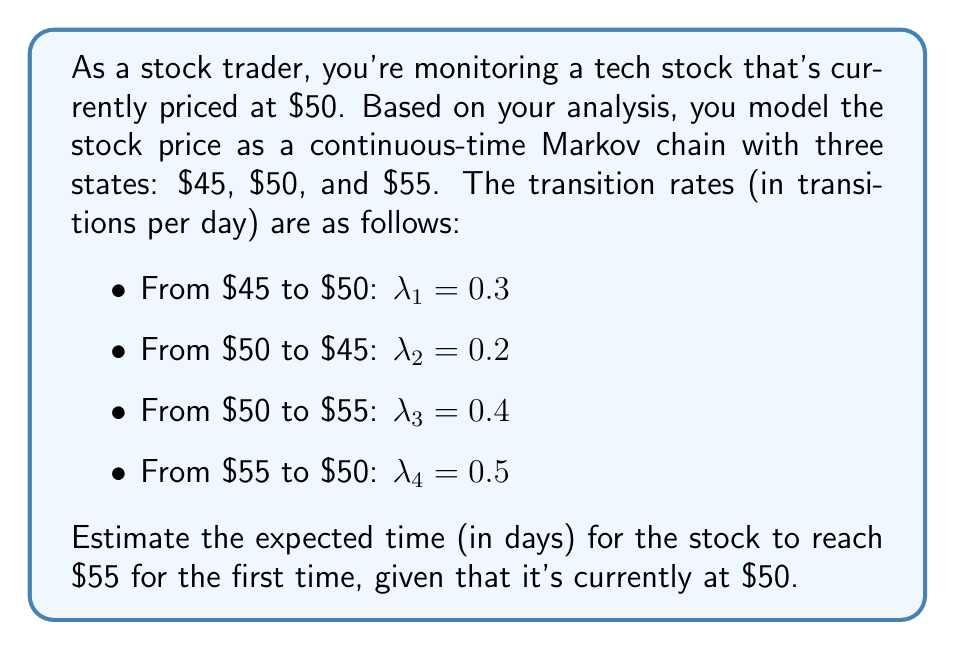Could you help me with this problem? To solve this problem, we'll use the concept of mean first passage time in continuous-time Markov chains. Let's approach this step-by-step:

1) Let $m_{ij}$ be the mean first passage time from state i to state j. We want to find $m_{50,55}$.

2) In this case, we have a three-state Markov chain. We can set up the following equations:

   $m_{50,55} = \frac{1}{\lambda_2 + \lambda_3} + \frac{\lambda_2}{\lambda_2 + \lambda_3}(m_{45,55})$

   $m_{45,55} = \frac{1}{\lambda_1} + m_{50,55}$

3) We have two equations and two unknowns. Let's solve for $m_{50,55}$:

4) Substitute the second equation into the first:

   $m_{50,55} = \frac{1}{\lambda_2 + \lambda_3} + \frac{\lambda_2}{\lambda_2 + \lambda_3}(\frac{1}{\lambda_1} + m_{50,55})$

5) Simplify:

   $m_{50,55} = \frac{1}{\lambda_2 + \lambda_3} + \frac{\lambda_2}{\lambda_1(\lambda_2 + \lambda_3)} + \frac{\lambda_2}{\lambda_2 + \lambda_3}m_{50,55}$

6) Solve for $m_{50,55}$:

   $m_{50,55}(1 - \frac{\lambda_2}{\lambda_2 + \lambda_3}) = \frac{1}{\lambda_2 + \lambda_3} + \frac{\lambda_2}{\lambda_1(\lambda_2 + \lambda_3)}$

   $m_{50,55} = \frac{\frac{1}{\lambda_2 + \lambda_3} + \frac{\lambda_2}{\lambda_1(\lambda_2 + \lambda_3)}}{1 - \frac{\lambda_2}{\lambda_2 + \lambda_3}}$

7) Now, let's substitute the given values:

   $\lambda_1 = 0.3, \lambda_2 = 0.2, \lambda_3 = 0.4$

8) Calculate:

   $m_{50,55} = \frac{\frac{1}{0.2 + 0.4} + \frac{0.2}{0.3(0.2 + 0.4)}}{1 - \frac{0.2}{0.2 + 0.4}}$

   $= \frac{\frac{1}{0.6} + \frac{0.2}{0.18}}{1 - \frac{1}{3}}$

   $= \frac{1.67 + 1.11}{0.67} \approx 4.15$ days

Therefore, the expected time for the stock to reach $55 for the first time, starting from $50, is approximately 4.15 days.
Answer: 4.15 days 